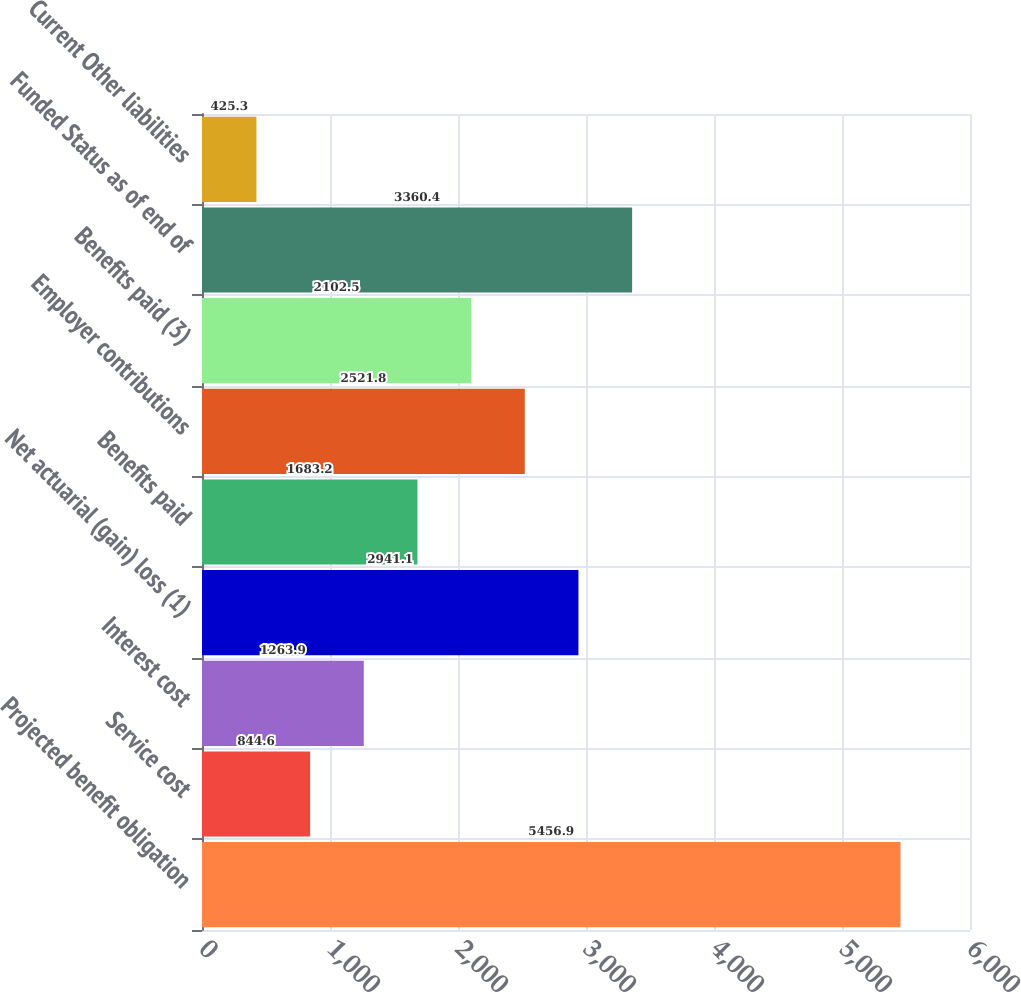<chart> <loc_0><loc_0><loc_500><loc_500><bar_chart><fcel>Projected benefit obligation<fcel>Service cost<fcel>Interest cost<fcel>Net actuarial (gain) loss (1)<fcel>Benefits paid<fcel>Employer contributions<fcel>Benefits paid (3)<fcel>Funded Status as of end of<fcel>Current Other liabilities<nl><fcel>5456.9<fcel>844.6<fcel>1263.9<fcel>2941.1<fcel>1683.2<fcel>2521.8<fcel>2102.5<fcel>3360.4<fcel>425.3<nl></chart> 